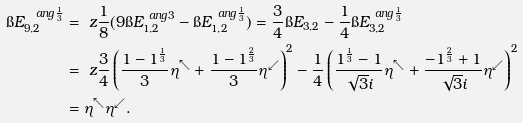Convert formula to latex. <formula><loc_0><loc_0><loc_500><loc_500>\i E _ { 9 , 2 } ^ { \ a n g { \frac { 1 } { 3 } } } & = \ z \frac { 1 } { 8 } ( 9 \i E _ { 1 , 2 } ^ { \ a n g 3 } - \i E _ { 1 , 2 } ^ { \ a n g { \frac { 1 } { 3 } } } ) = \frac { 3 } { 4 } \i E _ { 3 , 2 } - \frac { 1 } { 4 } \i E _ { 3 , 2 } ^ { \ a n g { \frac { 1 } { 3 } } } \\ & = \ z \frac { 3 } { 4 } \left ( \frac { 1 - 1 ^ { \frac { 1 } { 3 } } } 3 \eta ^ { \nwarrow } + \frac { 1 - 1 ^ { \frac { 2 } { 3 } } } 3 \eta ^ { \swarrow } \right ) ^ { 2 } - \frac { 1 } { 4 } \left ( \frac { 1 ^ { \frac { 1 } { 3 } } - 1 } { \sqrt { 3 } i } \eta ^ { \nwarrow } + \frac { - 1 ^ { \frac { 2 } { 3 } } + 1 } { \sqrt { 3 } i } \eta ^ { \swarrow } \right ) ^ { 2 } \\ & = \eta ^ { \nwarrow } \eta ^ { \swarrow } .</formula> 